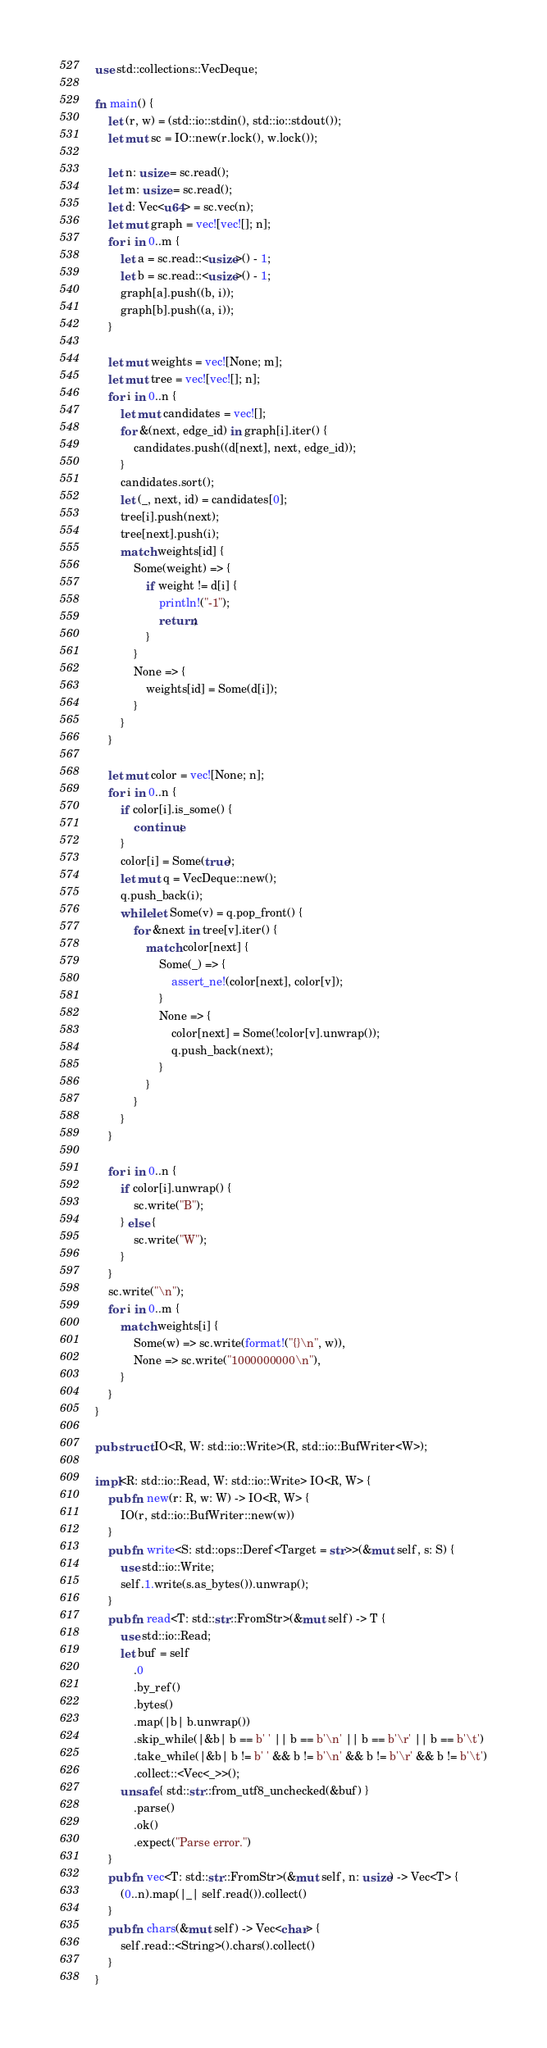<code> <loc_0><loc_0><loc_500><loc_500><_Rust_>use std::collections::VecDeque;

fn main() {
    let (r, w) = (std::io::stdin(), std::io::stdout());
    let mut sc = IO::new(r.lock(), w.lock());

    let n: usize = sc.read();
    let m: usize = sc.read();
    let d: Vec<u64> = sc.vec(n);
    let mut graph = vec![vec![]; n];
    for i in 0..m {
        let a = sc.read::<usize>() - 1;
        let b = sc.read::<usize>() - 1;
        graph[a].push((b, i));
        graph[b].push((a, i));
    }

    let mut weights = vec![None; m];
    let mut tree = vec![vec![]; n];
    for i in 0..n {
        let mut candidates = vec![];
        for &(next, edge_id) in graph[i].iter() {
            candidates.push((d[next], next, edge_id));
        }
        candidates.sort();
        let (_, next, id) = candidates[0];
        tree[i].push(next);
        tree[next].push(i);
        match weights[id] {
            Some(weight) => {
                if weight != d[i] {
                    println!("-1");
                    return;
                }
            }
            None => {
                weights[id] = Some(d[i]);
            }
        }
    }

    let mut color = vec![None; n];
    for i in 0..n {
        if color[i].is_some() {
            continue;
        }
        color[i] = Some(true);
        let mut q = VecDeque::new();
        q.push_back(i);
        while let Some(v) = q.pop_front() {
            for &next in tree[v].iter() {
                match color[next] {
                    Some(_) => {
                        assert_ne!(color[next], color[v]);
                    }
                    None => {
                        color[next] = Some(!color[v].unwrap());
                        q.push_back(next);
                    }
                }
            }
        }
    }

    for i in 0..n {
        if color[i].unwrap() {
            sc.write("B");
        } else {
            sc.write("W");
        }
    }
    sc.write("\n");
    for i in 0..m {
        match weights[i] {
            Some(w) => sc.write(format!("{}\n", w)),
            None => sc.write("1000000000\n"),
        }
    }
}

pub struct IO<R, W: std::io::Write>(R, std::io::BufWriter<W>);

impl<R: std::io::Read, W: std::io::Write> IO<R, W> {
    pub fn new(r: R, w: W) -> IO<R, W> {
        IO(r, std::io::BufWriter::new(w))
    }
    pub fn write<S: std::ops::Deref<Target = str>>(&mut self, s: S) {
        use std::io::Write;
        self.1.write(s.as_bytes()).unwrap();
    }
    pub fn read<T: std::str::FromStr>(&mut self) -> T {
        use std::io::Read;
        let buf = self
            .0
            .by_ref()
            .bytes()
            .map(|b| b.unwrap())
            .skip_while(|&b| b == b' ' || b == b'\n' || b == b'\r' || b == b'\t')
            .take_while(|&b| b != b' ' && b != b'\n' && b != b'\r' && b != b'\t')
            .collect::<Vec<_>>();
        unsafe { std::str::from_utf8_unchecked(&buf) }
            .parse()
            .ok()
            .expect("Parse error.")
    }
    pub fn vec<T: std::str::FromStr>(&mut self, n: usize) -> Vec<T> {
        (0..n).map(|_| self.read()).collect()
    }
    pub fn chars(&mut self) -> Vec<char> {
        self.read::<String>().chars().collect()
    }
}
</code> 